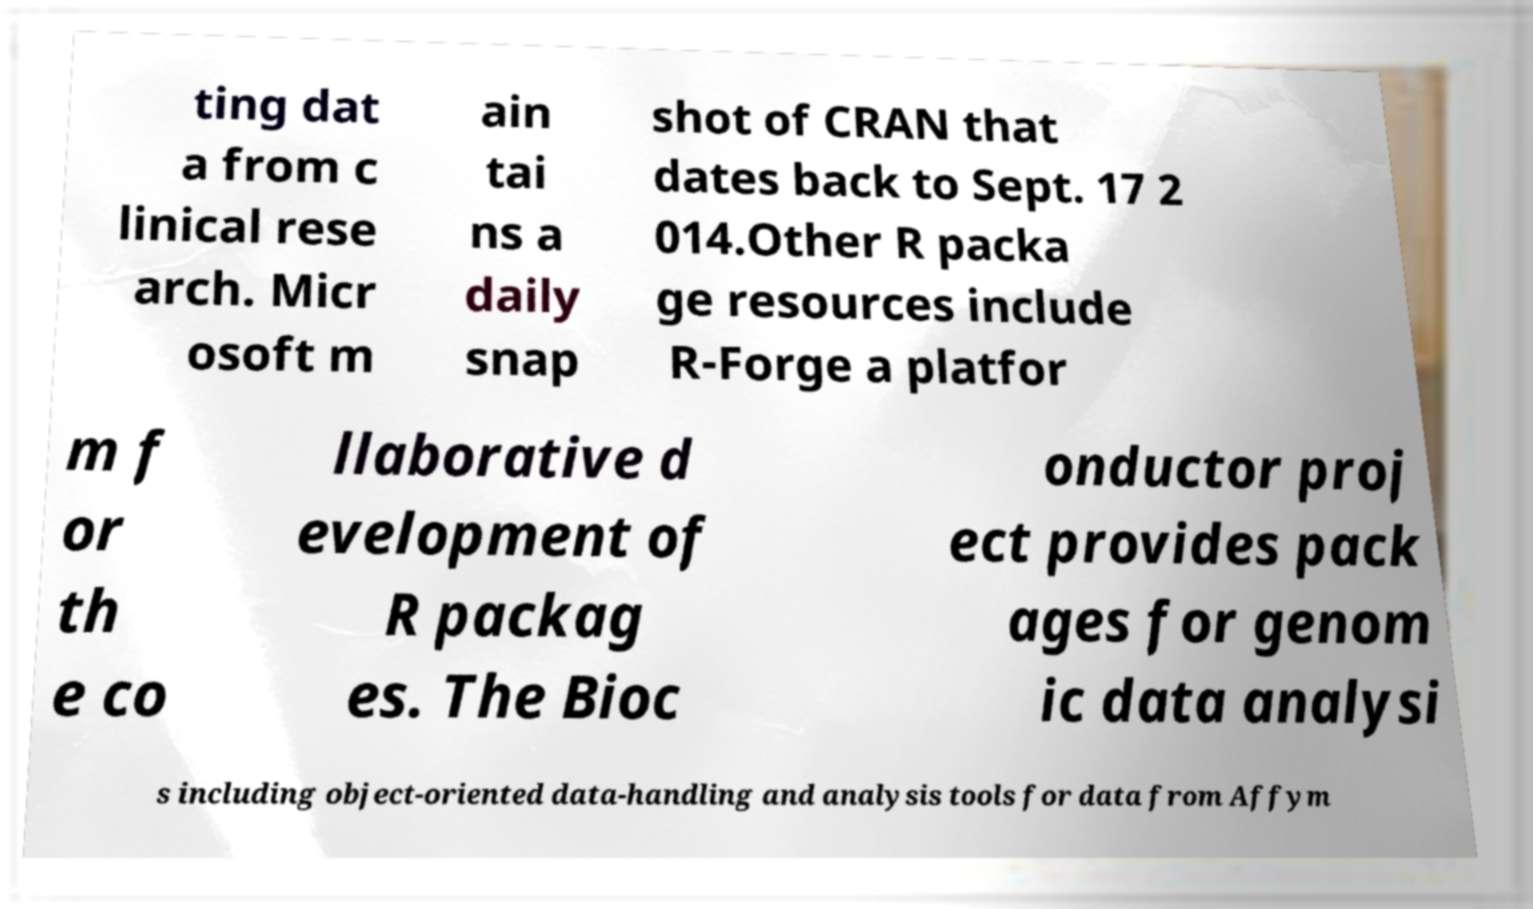There's text embedded in this image that I need extracted. Can you transcribe it verbatim? ting dat a from c linical rese arch. Micr osoft m ain tai ns a daily snap shot of CRAN that dates back to Sept. 17 2 014.Other R packa ge resources include R-Forge a platfor m f or th e co llaborative d evelopment of R packag es. The Bioc onductor proj ect provides pack ages for genom ic data analysi s including object-oriented data-handling and analysis tools for data from Affym 